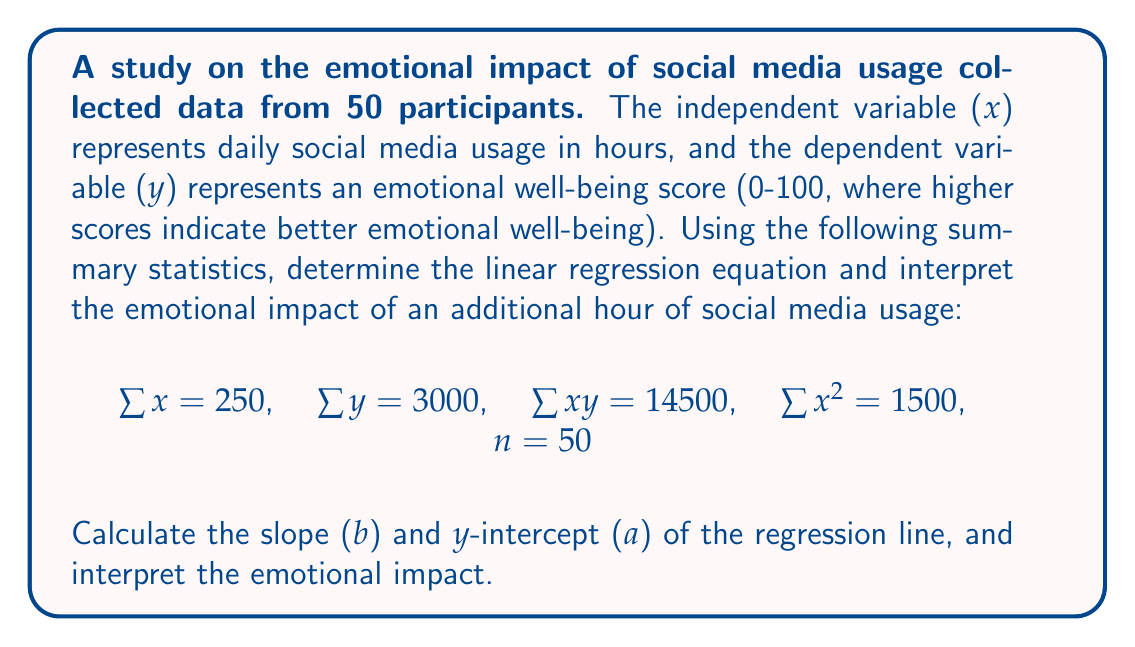Teach me how to tackle this problem. To find the linear regression equation, we need to calculate the slope (b) and y-intercept (a).

Step 1: Calculate the slope (b) using the formula:
$$b = \frac{n\sum xy - \sum x \sum y}{n\sum x^2 - (\sum x)^2}$$

Substituting the given values:
$$b = \frac{50(14500) - 250(3000)}{50(1500) - (250)^2}$$
$$b = \frac{725000 - 750000}{75000 - 62500} = \frac{-25000}{12500} = -2$$

Step 2: Calculate the y-intercept (a) using the formula:
$$a = \frac{\sum y - b\sum x}{n}$$

Substituting the values:
$$a = \frac{3000 - (-2)(250)}{50} = \frac{3000 + 500}{50} = \frac{3500}{50} = 70$$

Step 3: Write the linear regression equation:
$$y = a + bx$$
$$y = 70 - 2x$$

Step 4: Interpret the emotional impact:
The slope (b) represents the change in emotional well-being score for each additional hour of social media usage. In this case, b = -2, which means that for each additional hour of social media usage, the emotional well-being score decreases by 2 points on average.

This negative relationship suggests that increased social media usage is associated with lower emotional well-being scores, indicating a potentially negative emotional impact of social media use.
Answer: $y = 70 - 2x$; Each additional hour of social media use is associated with a 2-point decrease in emotional well-being score. 